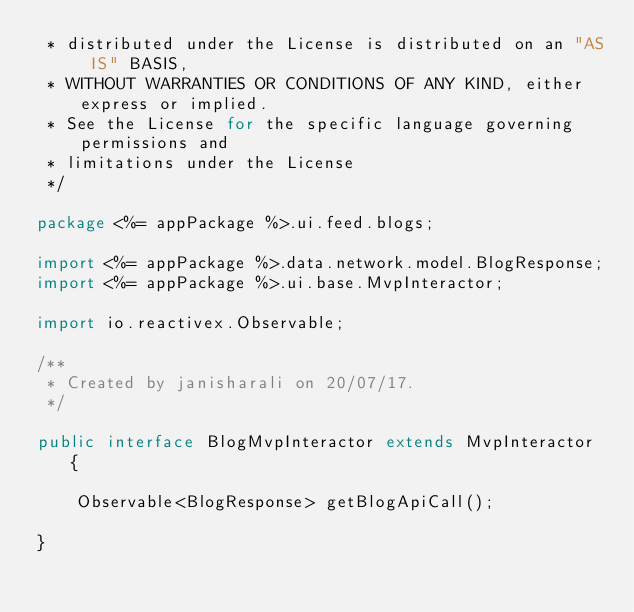Convert code to text. <code><loc_0><loc_0><loc_500><loc_500><_Java_> * distributed under the License is distributed on an "AS IS" BASIS,
 * WITHOUT WARRANTIES OR CONDITIONS OF ANY KIND, either express or implied.
 * See the License for the specific language governing permissions and
 * limitations under the License
 */

package <%= appPackage %>.ui.feed.blogs;

import <%= appPackage %>.data.network.model.BlogResponse;
import <%= appPackage %>.ui.base.MvpInteractor;

import io.reactivex.Observable;

/**
 * Created by janisharali on 20/07/17.
 */

public interface BlogMvpInteractor extends MvpInteractor {

    Observable<BlogResponse> getBlogApiCall();

}
</code> 